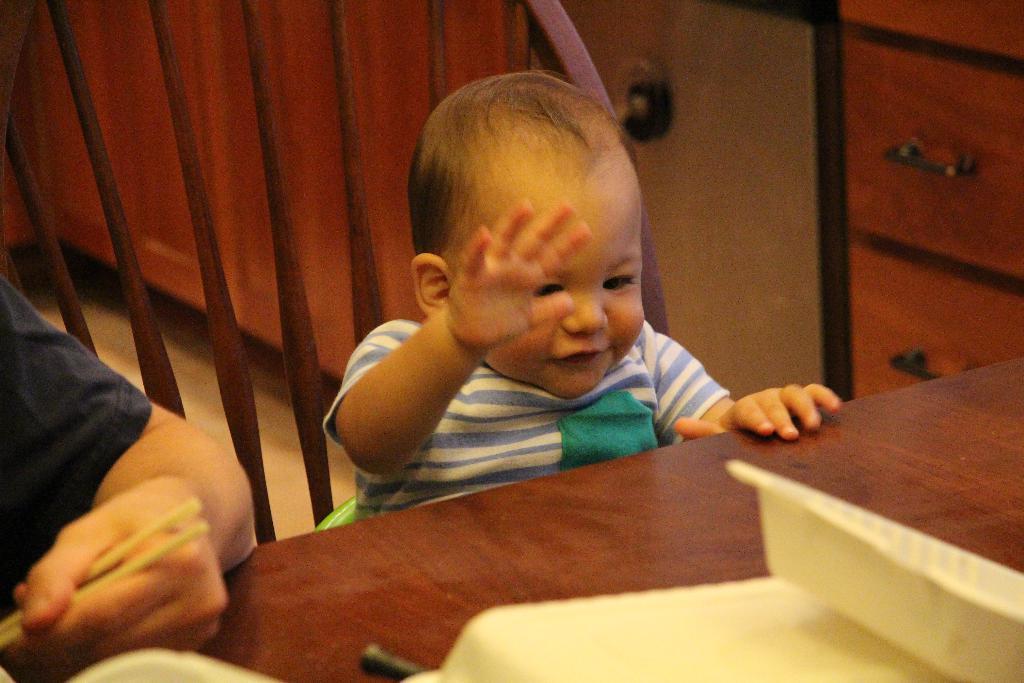Please provide a concise description of this image. In this image I see a baby and there is a person near to that baby and I see the person is holding chopsticks and there is a table in front of them. 